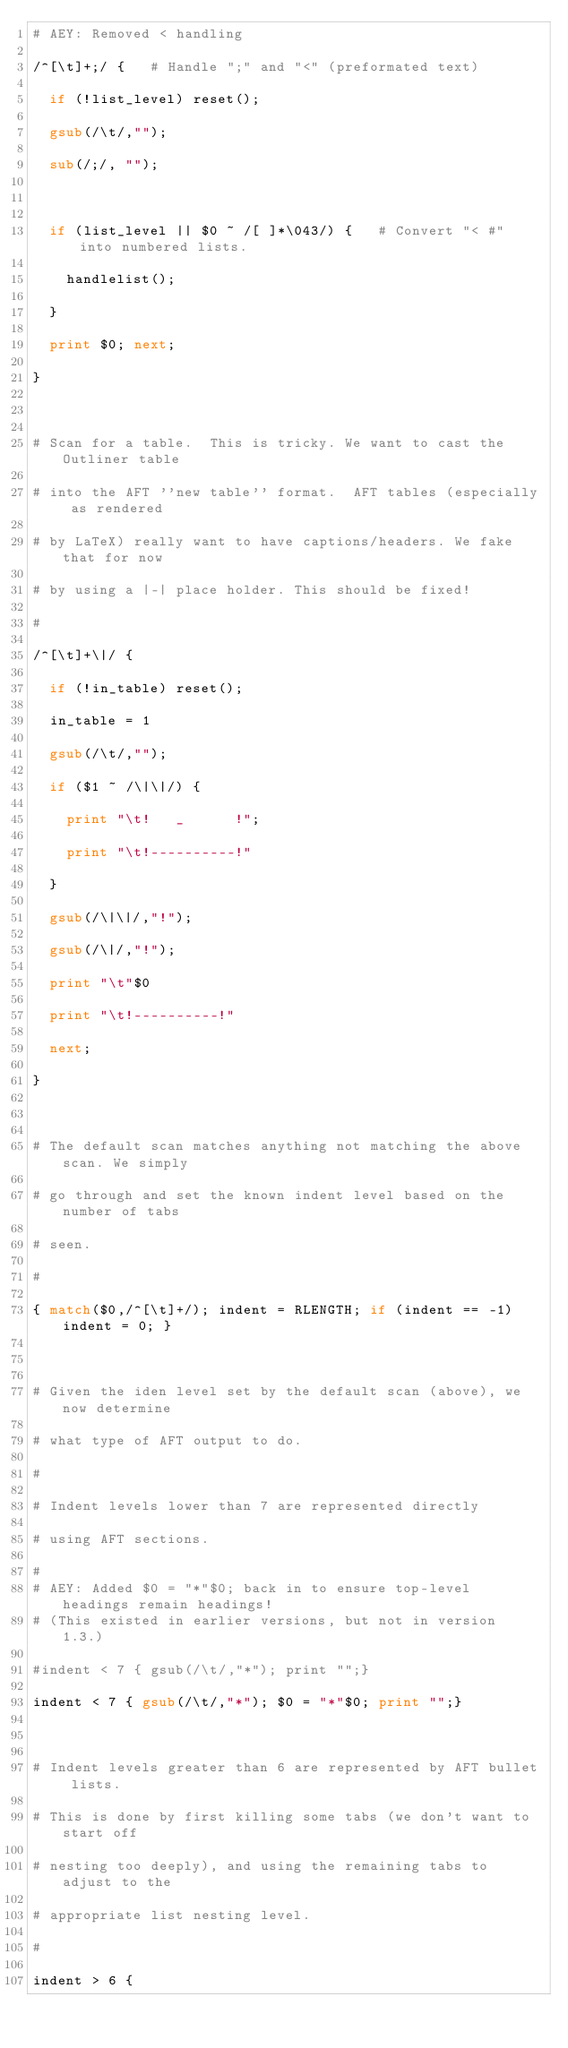<code> <loc_0><loc_0><loc_500><loc_500><_Awk_># AEY: Removed < handling
/^[\t]+;/ {		# Handle ";" and "<" (preformated text)
  if (!list_level) reset();
  gsub(/\t/,"");
  sub(/;/, "");

  if (list_level || $0 ~ /[ ]*\043/) {   # Convert "< #" into numbered lists.
    handlelist();
  }
  print $0; next;
}

# Scan for a table.  This is tricky. We want to cast the Outliner table
# into the AFT ''new table'' format.  AFT tables (especially as rendered
# by LaTeX) really want to have captions/headers. We fake that for now
# by using a |-| place holder. This should be fixed!
#
/^[\t]+\|/ {
  if (!in_table) reset();
  in_table = 1
  gsub(/\t/,"");
  if ($1 ~ /\|\|/) {
    print "\t!   _      !";
    print "\t!----------!"
  } 
  gsub(/\|\|/,"!");
  gsub(/\|/,"!");
  print "\t"$0
  print "\t!----------!"
  next;
}

# The default scan matches anything not matching the above scan. We simply
# go through and set the known indent level based on the number of tabs
# seen.
#
{ match($0,/^[\t]+/); indent = RLENGTH; if (indent == -1) indent = 0; }

# Given the iden level set by the default scan (above), we now determine
# what type of AFT output to do. 
#
# Indent levels lower than 7 are represented directly
# using AFT sections.
#
# AEY: Added $0 = "*"$0; back in to ensure top-level headings remain headings!
# (This existed in earlier versions, but not in version 1.3.)
#indent < 7 { gsub(/\t/,"*"); print "";}
indent < 7 { gsub(/\t/,"*"); $0 = "*"$0; print "";}

# Indent levels greater than 6 are represented by AFT bullet lists.
# This is done by first killing some tabs (we don't want to start off
# nesting too deeply), and using the remaining tabs to adjust to the 
# appropriate list nesting level.
#
indent > 6 { </code> 